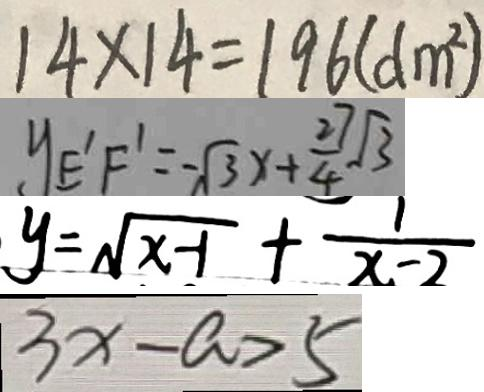<formula> <loc_0><loc_0><loc_500><loc_500>1 4 \times 1 4 = 1 9 6 ( d m ^ { 2 } ) 
 y _ { E ^ { \prime } F ^ { \prime } } = - \sqrt { 3 } x + \frac { 2 7 } { 4 } \sqrt { 3 } 
 y = \sqrt { x - 1 } + \frac { 1 } { x - 2 } 
 3 x - a > 5</formula> 